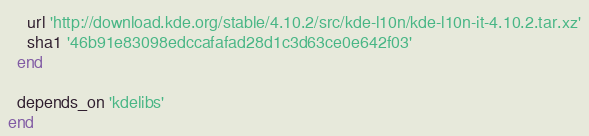Convert code to text. <code><loc_0><loc_0><loc_500><loc_500><_Ruby_>    url 'http://download.kde.org/stable/4.10.2/src/kde-l10n/kde-l10n-it-4.10.2.tar.xz'
    sha1 '46b91e83098edccafafad28d1c3d63ce0e642f03'
  end

  depends_on 'kdelibs'
end
</code> 